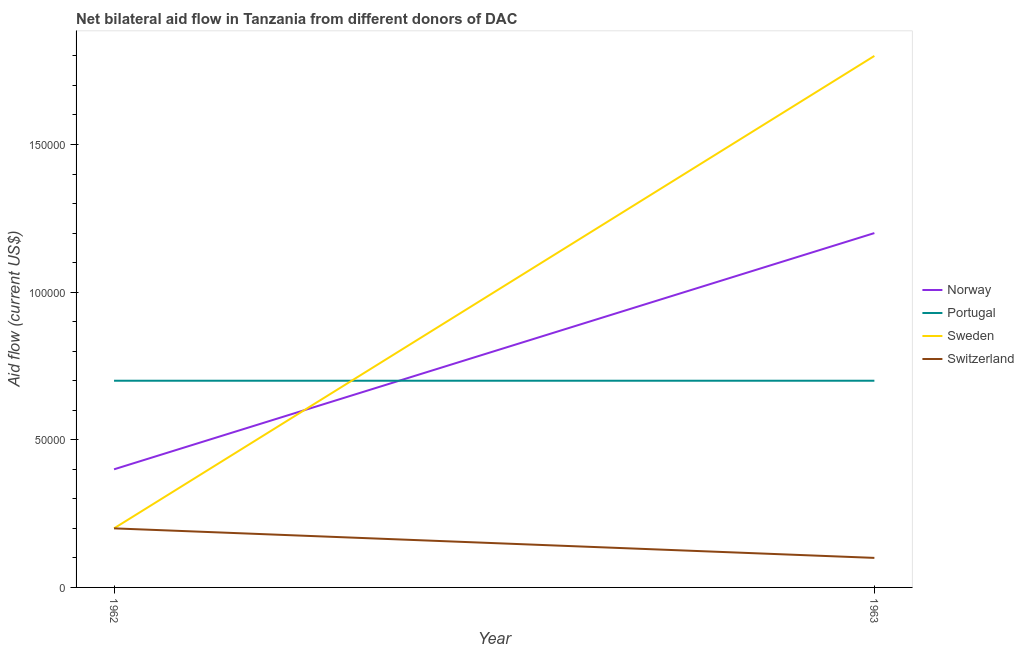Does the line corresponding to amount of aid given by sweden intersect with the line corresponding to amount of aid given by portugal?
Keep it short and to the point. Yes. What is the amount of aid given by norway in 1963?
Provide a short and direct response. 1.20e+05. Across all years, what is the maximum amount of aid given by sweden?
Offer a very short reply. 1.80e+05. Across all years, what is the minimum amount of aid given by norway?
Your response must be concise. 4.00e+04. In which year was the amount of aid given by norway minimum?
Ensure brevity in your answer.  1962. What is the total amount of aid given by portugal in the graph?
Keep it short and to the point. 1.40e+05. What is the difference between the amount of aid given by switzerland in 1962 and that in 1963?
Keep it short and to the point. 10000. What is the difference between the amount of aid given by norway in 1962 and the amount of aid given by portugal in 1963?
Give a very brief answer. -3.00e+04. What is the average amount of aid given by switzerland per year?
Provide a short and direct response. 1.50e+04. In the year 1962, what is the difference between the amount of aid given by norway and amount of aid given by sweden?
Your answer should be compact. 2.00e+04. In how many years, is the amount of aid given by sweden greater than 130000 US$?
Offer a very short reply. 1. Is the amount of aid given by sweden in 1962 less than that in 1963?
Keep it short and to the point. Yes. In how many years, is the amount of aid given by switzerland greater than the average amount of aid given by switzerland taken over all years?
Provide a succinct answer. 1. Is the amount of aid given by sweden strictly greater than the amount of aid given by portugal over the years?
Keep it short and to the point. No. How many years are there in the graph?
Ensure brevity in your answer.  2. What is the difference between two consecutive major ticks on the Y-axis?
Offer a terse response. 5.00e+04. Where does the legend appear in the graph?
Ensure brevity in your answer.  Center right. How are the legend labels stacked?
Offer a terse response. Vertical. What is the title of the graph?
Ensure brevity in your answer.  Net bilateral aid flow in Tanzania from different donors of DAC. What is the label or title of the Y-axis?
Provide a succinct answer. Aid flow (current US$). What is the Aid flow (current US$) of Norway in 1962?
Offer a very short reply. 4.00e+04. What is the Aid flow (current US$) of Sweden in 1962?
Offer a terse response. 2.00e+04. What is the Aid flow (current US$) in Switzerland in 1962?
Keep it short and to the point. 2.00e+04. What is the Aid flow (current US$) of Portugal in 1963?
Provide a succinct answer. 7.00e+04. What is the Aid flow (current US$) in Switzerland in 1963?
Your answer should be compact. 10000. Across all years, what is the maximum Aid flow (current US$) in Norway?
Your answer should be very brief. 1.20e+05. Across all years, what is the minimum Aid flow (current US$) in Norway?
Make the answer very short. 4.00e+04. Across all years, what is the minimum Aid flow (current US$) of Switzerland?
Make the answer very short. 10000. What is the total Aid flow (current US$) in Norway in the graph?
Make the answer very short. 1.60e+05. What is the total Aid flow (current US$) in Portugal in the graph?
Keep it short and to the point. 1.40e+05. What is the total Aid flow (current US$) in Switzerland in the graph?
Ensure brevity in your answer.  3.00e+04. What is the difference between the Aid flow (current US$) of Norway in 1962 and that in 1963?
Make the answer very short. -8.00e+04. What is the difference between the Aid flow (current US$) in Sweden in 1962 and that in 1963?
Ensure brevity in your answer.  -1.60e+05. What is the difference between the Aid flow (current US$) in Switzerland in 1962 and that in 1963?
Ensure brevity in your answer.  10000. What is the difference between the Aid flow (current US$) in Norway in 1962 and the Aid flow (current US$) in Sweden in 1963?
Provide a succinct answer. -1.40e+05. What is the difference between the Aid flow (current US$) of Norway in 1962 and the Aid flow (current US$) of Switzerland in 1963?
Make the answer very short. 3.00e+04. What is the difference between the Aid flow (current US$) of Portugal in 1962 and the Aid flow (current US$) of Sweden in 1963?
Your answer should be very brief. -1.10e+05. What is the average Aid flow (current US$) of Portugal per year?
Ensure brevity in your answer.  7.00e+04. What is the average Aid flow (current US$) in Sweden per year?
Make the answer very short. 1.00e+05. What is the average Aid flow (current US$) of Switzerland per year?
Provide a succinct answer. 1.50e+04. In the year 1962, what is the difference between the Aid flow (current US$) of Norway and Aid flow (current US$) of Portugal?
Offer a terse response. -3.00e+04. In the year 1962, what is the difference between the Aid flow (current US$) of Norway and Aid flow (current US$) of Sweden?
Provide a succinct answer. 2.00e+04. In the year 1962, what is the difference between the Aid flow (current US$) of Portugal and Aid flow (current US$) of Sweden?
Keep it short and to the point. 5.00e+04. In the year 1962, what is the difference between the Aid flow (current US$) of Portugal and Aid flow (current US$) of Switzerland?
Provide a short and direct response. 5.00e+04. In the year 1963, what is the difference between the Aid flow (current US$) of Norway and Aid flow (current US$) of Sweden?
Keep it short and to the point. -6.00e+04. In the year 1963, what is the difference between the Aid flow (current US$) in Norway and Aid flow (current US$) in Switzerland?
Your answer should be very brief. 1.10e+05. In the year 1963, what is the difference between the Aid flow (current US$) in Sweden and Aid flow (current US$) in Switzerland?
Your answer should be very brief. 1.70e+05. What is the ratio of the Aid flow (current US$) of Norway in 1962 to that in 1963?
Your answer should be compact. 0.33. What is the ratio of the Aid flow (current US$) in Portugal in 1962 to that in 1963?
Provide a short and direct response. 1. What is the ratio of the Aid flow (current US$) in Sweden in 1962 to that in 1963?
Your response must be concise. 0.11. What is the difference between the highest and the second highest Aid flow (current US$) in Norway?
Offer a very short reply. 8.00e+04. What is the difference between the highest and the second highest Aid flow (current US$) of Sweden?
Provide a succinct answer. 1.60e+05. What is the difference between the highest and the lowest Aid flow (current US$) of Norway?
Provide a succinct answer. 8.00e+04. What is the difference between the highest and the lowest Aid flow (current US$) of Portugal?
Make the answer very short. 0. What is the difference between the highest and the lowest Aid flow (current US$) of Sweden?
Ensure brevity in your answer.  1.60e+05. 